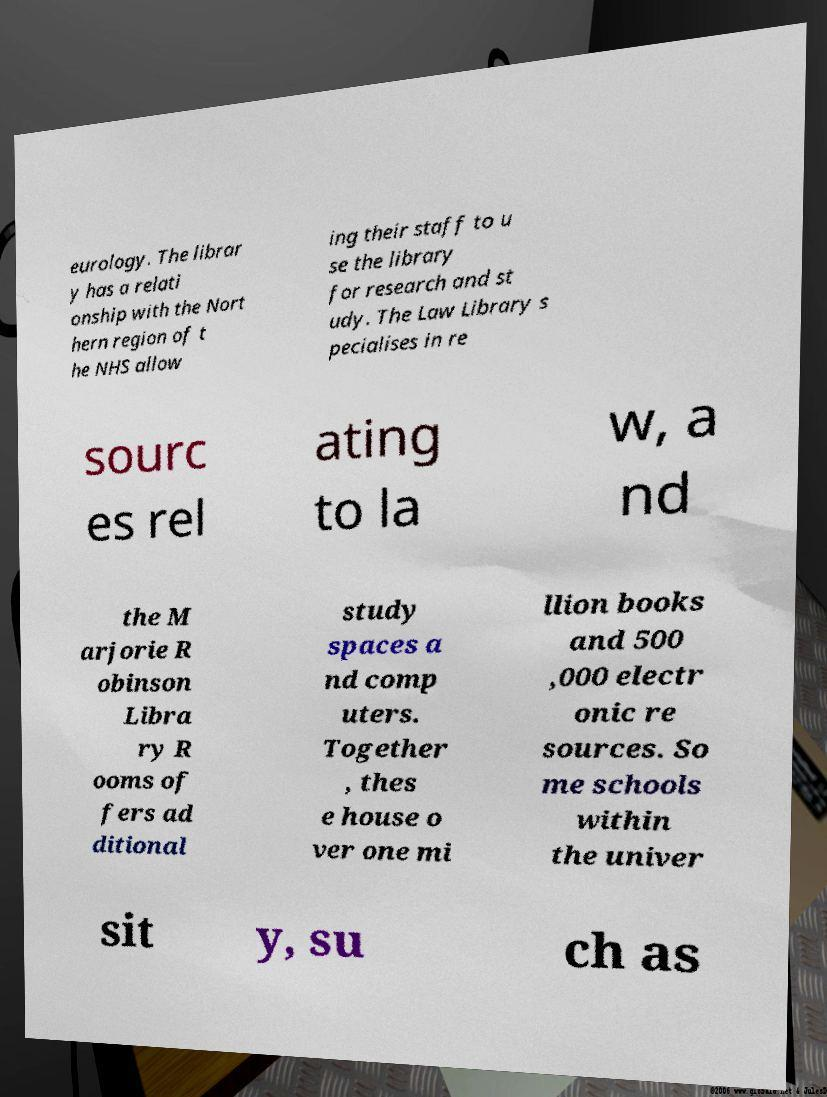Please identify and transcribe the text found in this image. eurology. The librar y has a relati onship with the Nort hern region of t he NHS allow ing their staff to u se the library for research and st udy. The Law Library s pecialises in re sourc es rel ating to la w, a nd the M arjorie R obinson Libra ry R ooms of fers ad ditional study spaces a nd comp uters. Together , thes e house o ver one mi llion books and 500 ,000 electr onic re sources. So me schools within the univer sit y, su ch as 